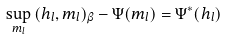<formula> <loc_0><loc_0><loc_500><loc_500>\sup _ { m _ { l } } \, ( h _ { l } , m _ { l } ) _ { \beta } - \Psi ( m _ { l } ) = \Psi ^ { * } ( h _ { l } )</formula> 